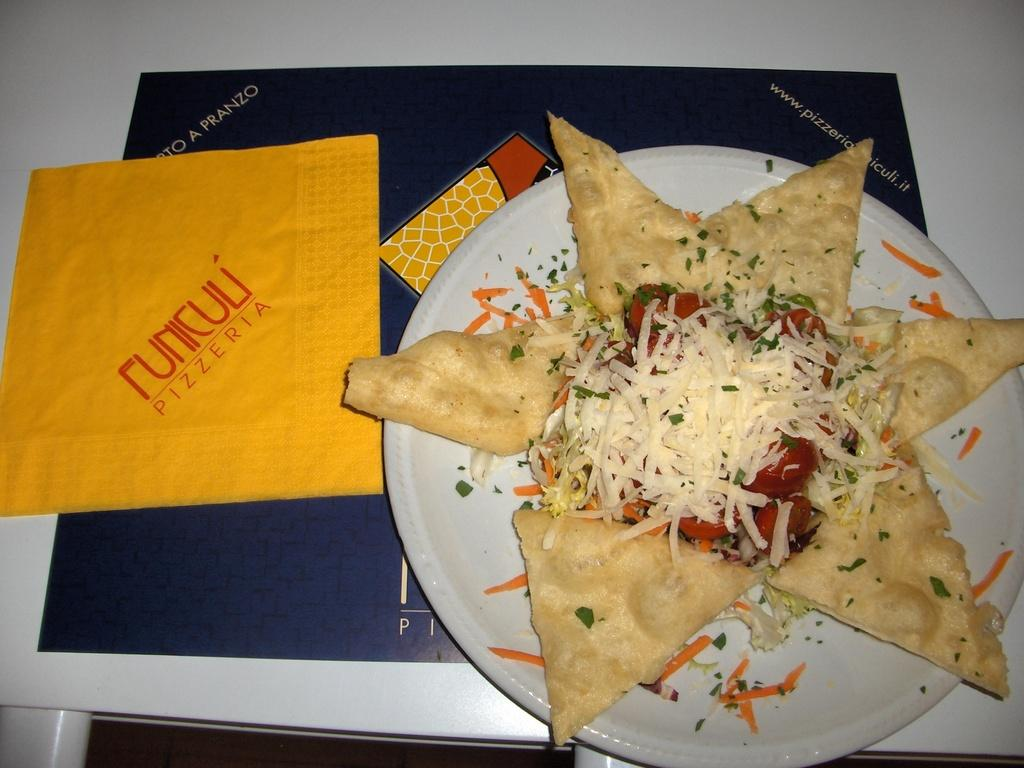<image>
Give a short and clear explanation of the subsequent image. A plate of food and the word pizzeria on the napkin. 